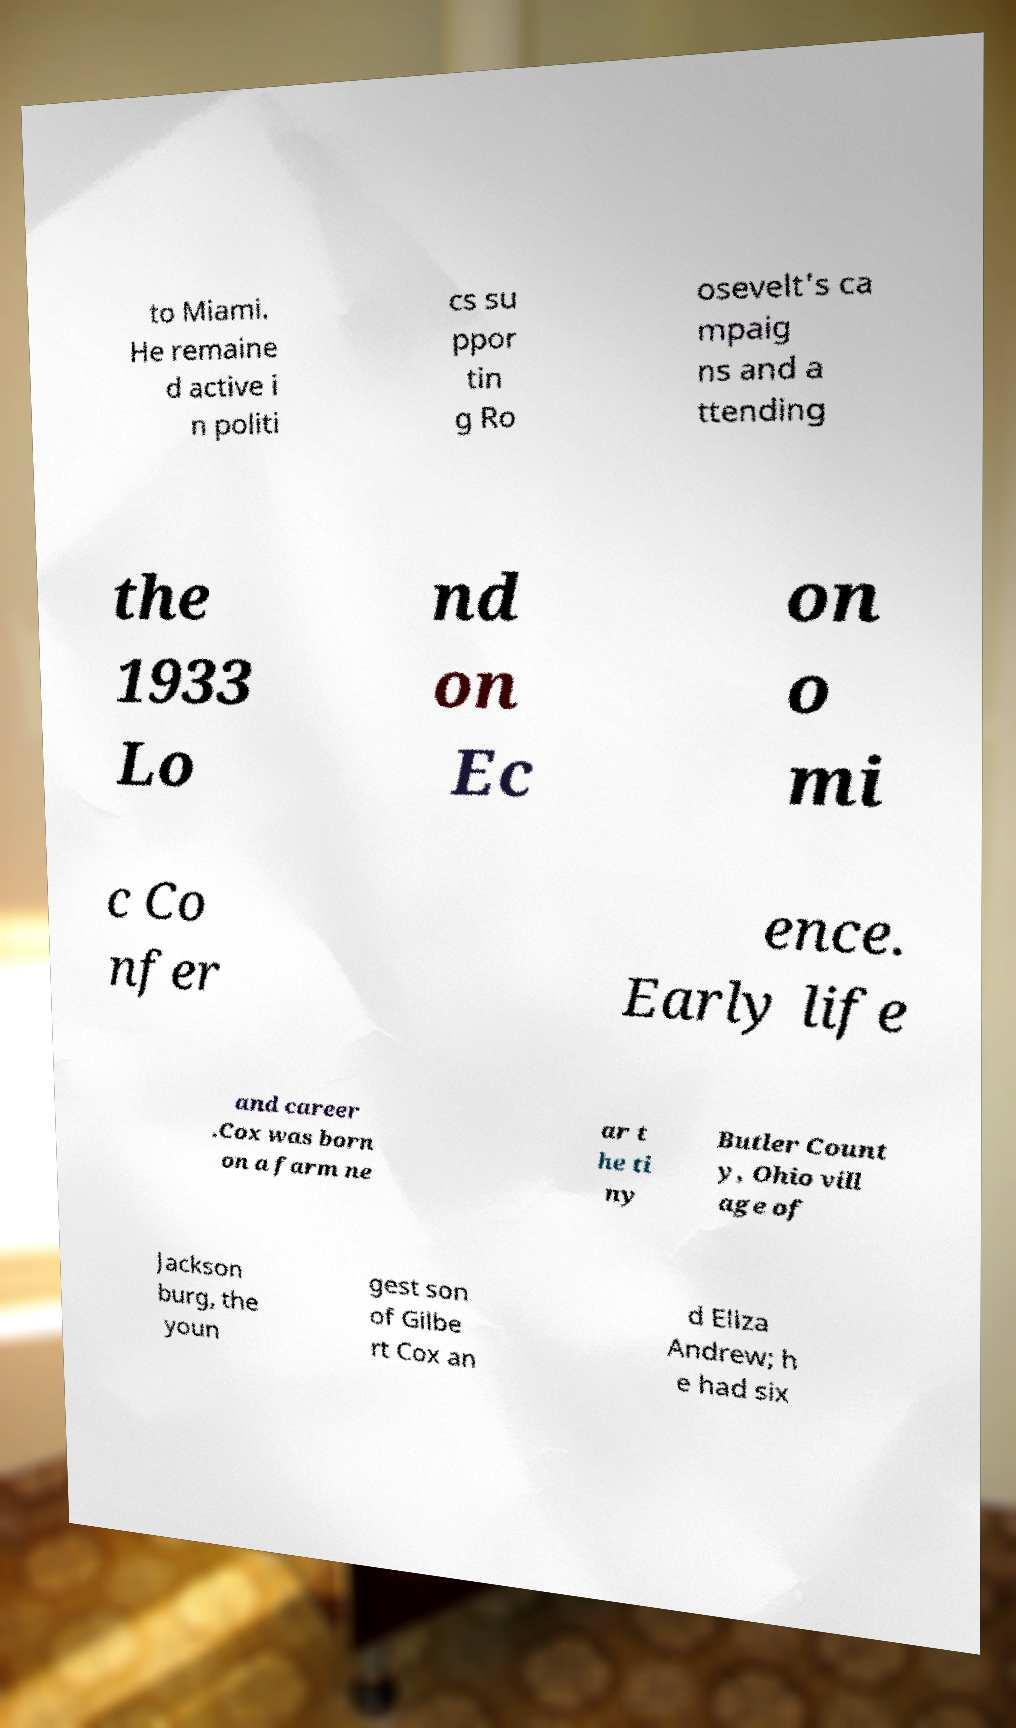Can you read and provide the text displayed in the image?This photo seems to have some interesting text. Can you extract and type it out for me? to Miami. He remaine d active i n politi cs su ppor tin g Ro osevelt's ca mpaig ns and a ttending the 1933 Lo nd on Ec on o mi c Co nfer ence. Early life and career .Cox was born on a farm ne ar t he ti ny Butler Count y, Ohio vill age of Jackson burg, the youn gest son of Gilbe rt Cox an d Eliza Andrew; h e had six 